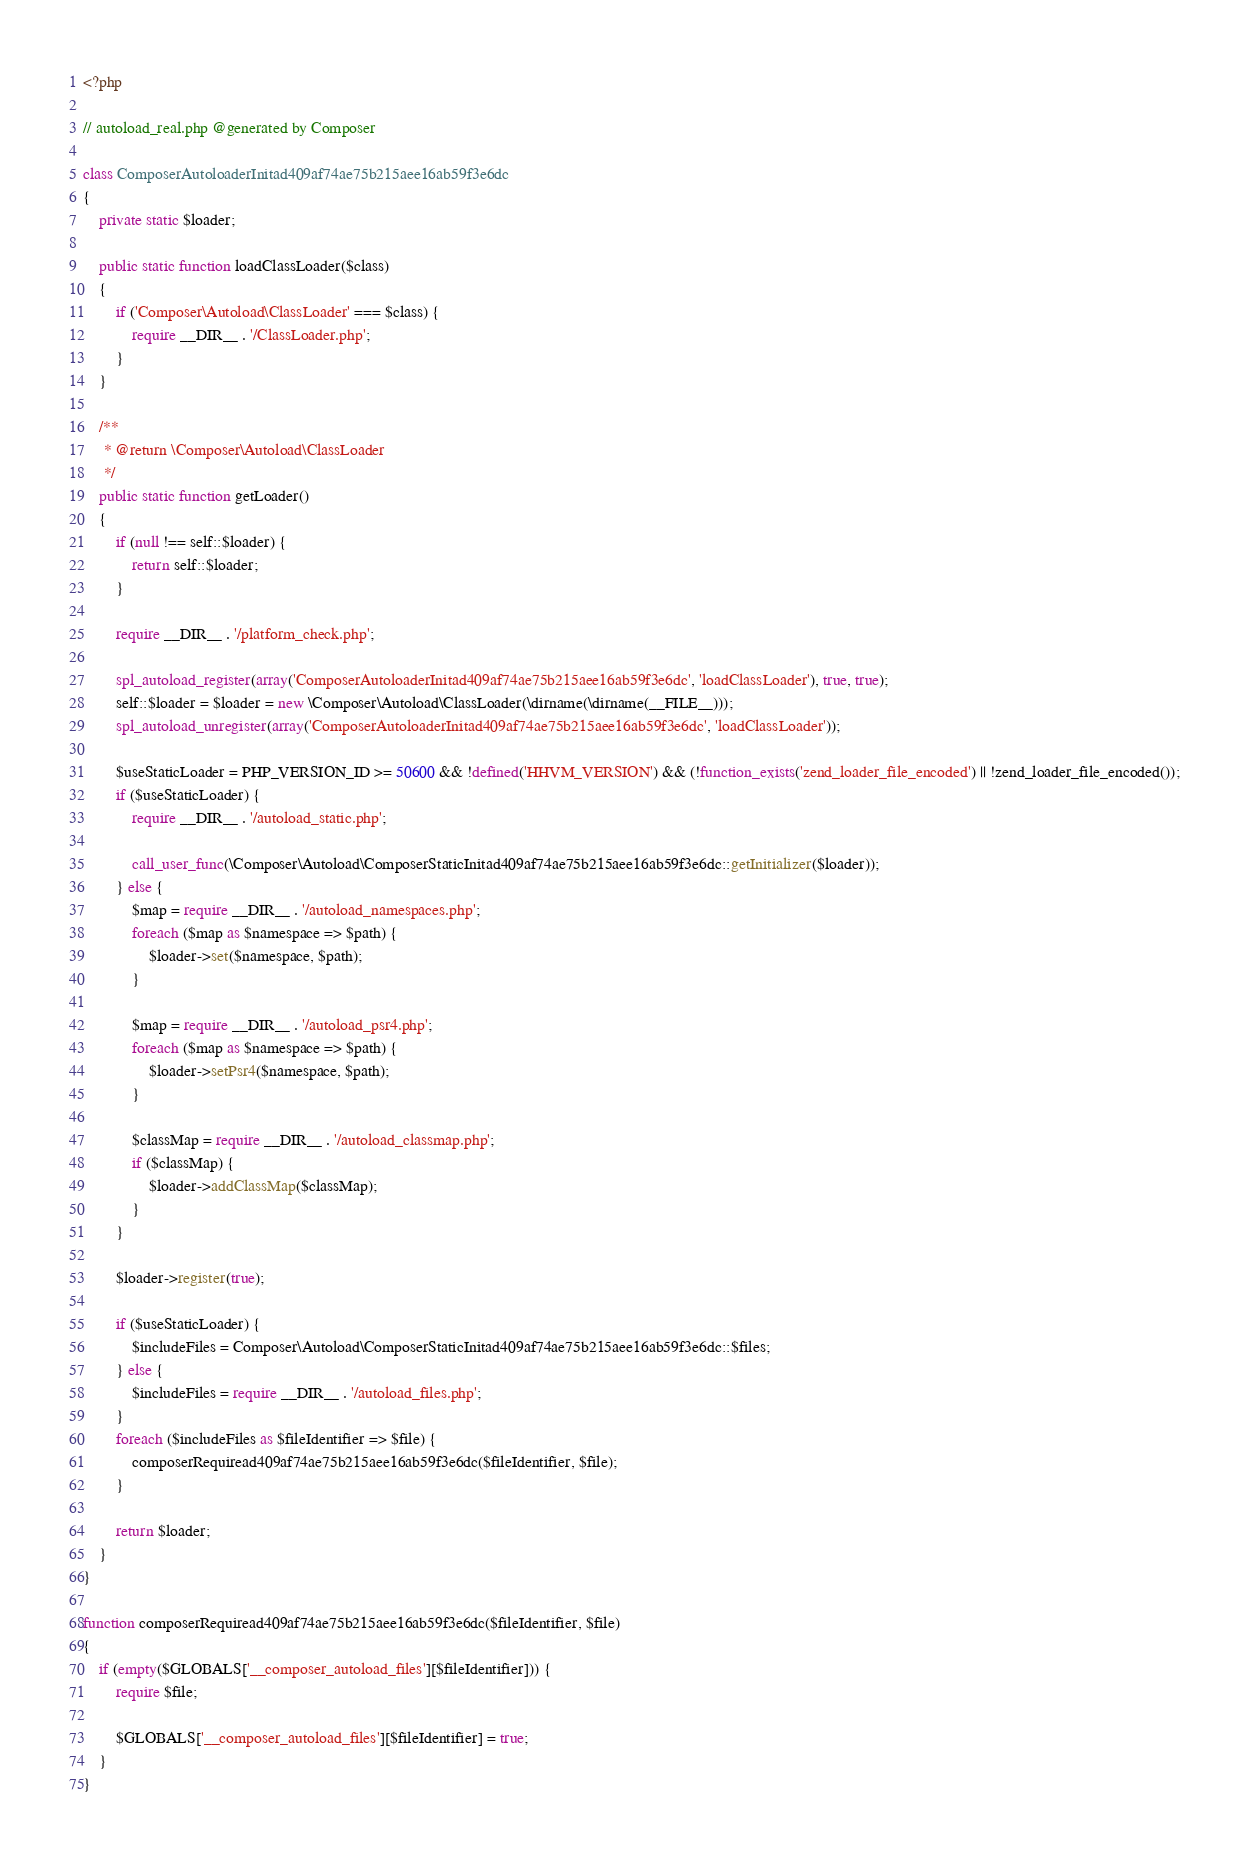<code> <loc_0><loc_0><loc_500><loc_500><_PHP_><?php

// autoload_real.php @generated by Composer

class ComposerAutoloaderInitad409af74ae75b215aee16ab59f3e6dc
{
    private static $loader;

    public static function loadClassLoader($class)
    {
        if ('Composer\Autoload\ClassLoader' === $class) {
            require __DIR__ . '/ClassLoader.php';
        }
    }

    /**
     * @return \Composer\Autoload\ClassLoader
     */
    public static function getLoader()
    {
        if (null !== self::$loader) {
            return self::$loader;
        }

        require __DIR__ . '/platform_check.php';

        spl_autoload_register(array('ComposerAutoloaderInitad409af74ae75b215aee16ab59f3e6dc', 'loadClassLoader'), true, true);
        self::$loader = $loader = new \Composer\Autoload\ClassLoader(\dirname(\dirname(__FILE__)));
        spl_autoload_unregister(array('ComposerAutoloaderInitad409af74ae75b215aee16ab59f3e6dc', 'loadClassLoader'));

        $useStaticLoader = PHP_VERSION_ID >= 50600 && !defined('HHVM_VERSION') && (!function_exists('zend_loader_file_encoded') || !zend_loader_file_encoded());
        if ($useStaticLoader) {
            require __DIR__ . '/autoload_static.php';

            call_user_func(\Composer\Autoload\ComposerStaticInitad409af74ae75b215aee16ab59f3e6dc::getInitializer($loader));
        } else {
            $map = require __DIR__ . '/autoload_namespaces.php';
            foreach ($map as $namespace => $path) {
                $loader->set($namespace, $path);
            }

            $map = require __DIR__ . '/autoload_psr4.php';
            foreach ($map as $namespace => $path) {
                $loader->setPsr4($namespace, $path);
            }

            $classMap = require __DIR__ . '/autoload_classmap.php';
            if ($classMap) {
                $loader->addClassMap($classMap);
            }
        }

        $loader->register(true);

        if ($useStaticLoader) {
            $includeFiles = Composer\Autoload\ComposerStaticInitad409af74ae75b215aee16ab59f3e6dc::$files;
        } else {
            $includeFiles = require __DIR__ . '/autoload_files.php';
        }
        foreach ($includeFiles as $fileIdentifier => $file) {
            composerRequiread409af74ae75b215aee16ab59f3e6dc($fileIdentifier, $file);
        }

        return $loader;
    }
}

function composerRequiread409af74ae75b215aee16ab59f3e6dc($fileIdentifier, $file)
{
    if (empty($GLOBALS['__composer_autoload_files'][$fileIdentifier])) {
        require $file;

        $GLOBALS['__composer_autoload_files'][$fileIdentifier] = true;
    }
}
</code> 